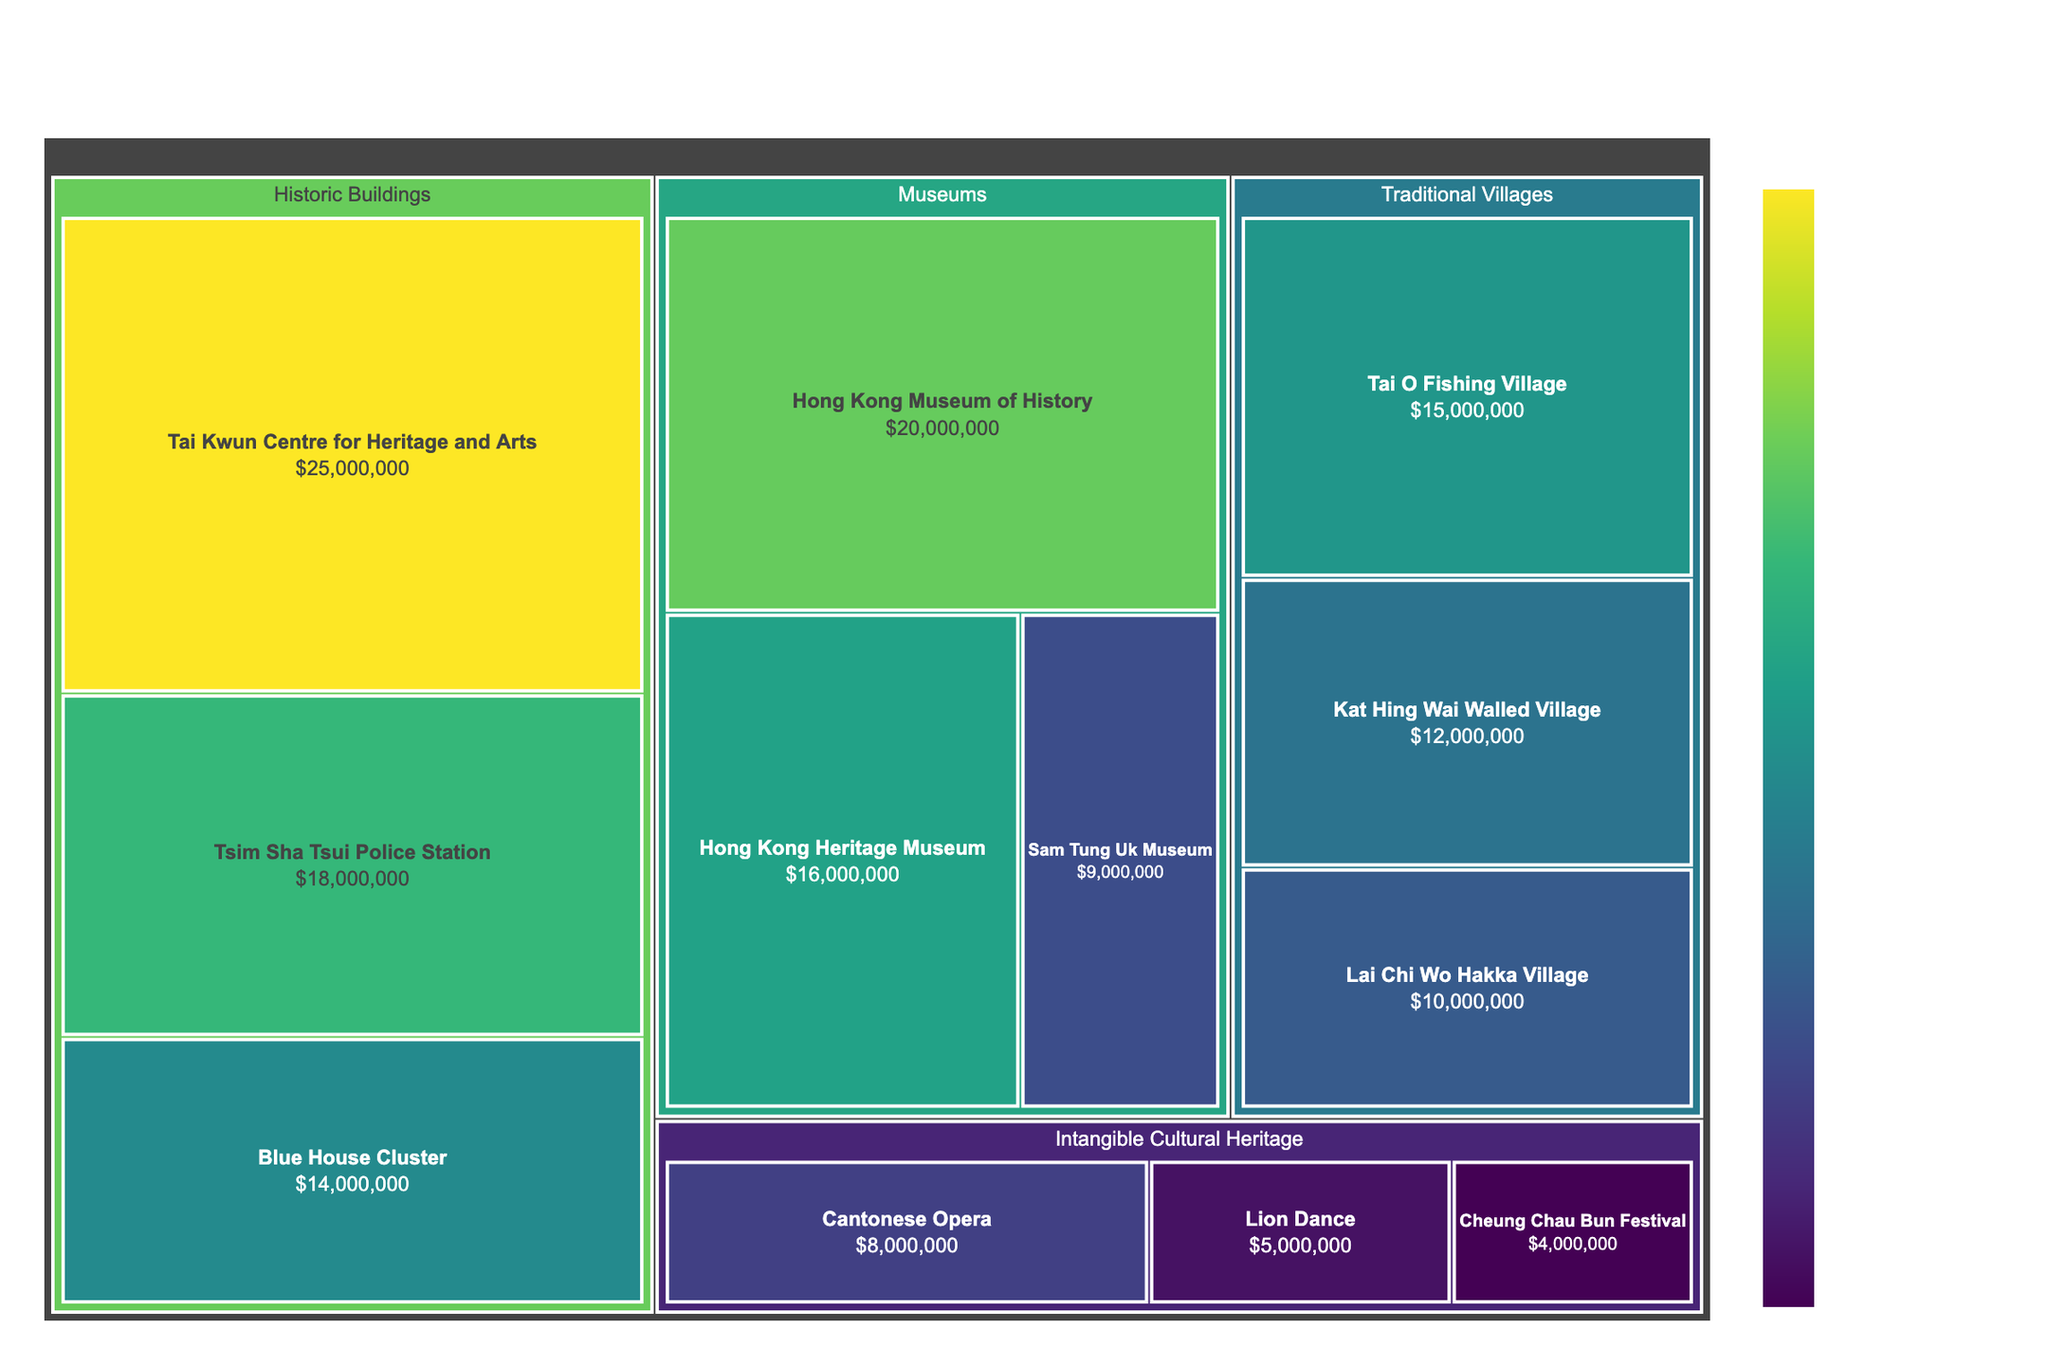What is the title of the treemap? The title of a treemap is usually placed at the top of the figure and is indicated in a larger and bolder font. In this case, the title is "Allocation of Government Funding for Cultural Preservation in Hong Kong" as it is mentioned in the code's title parameter.
Answer: Allocation of Government Funding for Cultural Preservation in Hong Kong What is the subcategory with the highest allocation under "Traditional Villages"? To find this, look at the subcategories under "Traditional Villages". The funding amounts for each are: Tai O Fishing Village ($15,000,000), Kat Hing Wai Walled Village ($12,000,000), and Lai Chi Wo Hakka Village ($10,000,000). The highest of these is Tai O Fishing Village.
Answer: Tai O Fishing Village Which subcategory in "Intangible Cultural Heritage" has the smallest funding? The funding amounts for the subcategories in "Intangible Cultural Heritage" are: Cantonese Opera ($8,000,000), Lion Dance ($5,000,000), and Cheung Chau Bun Festival ($4,000,000). The smallest allocation goes to the Cheung Chau Bun Festival.
Answer: Cheung Chau Bun Festival What is the total allocation for the "Museums" category? Add the amounts for the subcategories under "Museums": Hong Kong Museum of History ($20,000,000), Hong Kong Heritage Museum ($16,000,000), and Sam Tung Uk Museum ($9,000,000). The total is $20,000,000 + $16,000,000 + $9,000,000 = $45,000,000.
Answer: $45,000,000 Compare the funding between "Historic Buildings" and "Traditional Villages". Which category has more funding and by how much? Sum the allocations for each category first. For "Historic Buildings", the sums are: Tai Kwun Centre for Heritage and Arts ($25,000,000), Tsim Sha Tsui Police Station ($18,000,000), and Blue House Cluster ($14,000,000) giving a total of $57,000,000. For "Traditional Villages", the sums are: Tai O Fishing Village ($15,000,000), Kat Hing Wai Walled Village ($12,000,000), and Lai Chi Wo Hakka Village ($10,000,000), giving a total of $37,000,000. "Historic Buildings" has more by $57,000,000 - $37,000,000 = $20,000,000.
Answer: Historic Buildings by $20,000,000 How much more funding does the "Hong Kong Museum of History" receive compared to the "Sam Tung Uk Museum"? Find the difference between the two amounts. Hong Kong Museum of History receives $20,000,000 and Sam Tung Uk Museum receives $9,000,000. The difference is $20,000,000 - $9,000,000 = $11,000,000.
Answer: $11,000,000 What percentage of the total allocation is given to "Cantonese Opera" within its category? First, find the total allocation for "Intangible Cultural Heritage" by summing the subcategory amounts: Cantonese Opera ($8,000,000), Lion Dance ($5,000,000), and Cheung Chau Bun Festival ($4,000,000), which is $17,000,000. Then, use the formula (funded amount/total amount) * 100. This gives ($8,000,000 / $17,000,000) * 100 ≈ 47.06%.
Answer: 47.06% Which category has the highest single subcategory allocation, and what is the amount? By examining the amounts, the highest single allocation is for "Tai Kwun Centre for Heritage and Arts" under the category "Historic Buildings", with $25,000,000.
Answer: Historic Buildings, $25,000,000 In which category does the "Blue House Cluster" belong? From the given subcategories, the Blue House Cluster is listed under the "Historic Buildings" category.
Answer: Historic Buildings 